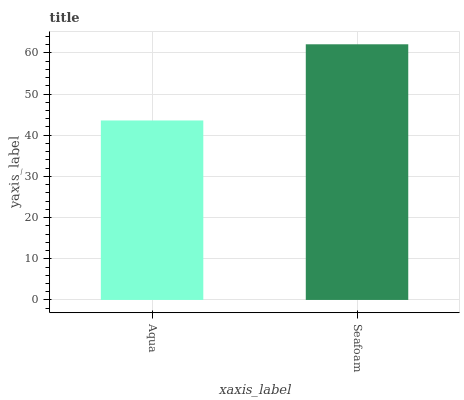Is Aqua the minimum?
Answer yes or no. Yes. Is Seafoam the maximum?
Answer yes or no. Yes. Is Seafoam the minimum?
Answer yes or no. No. Is Seafoam greater than Aqua?
Answer yes or no. Yes. Is Aqua less than Seafoam?
Answer yes or no. Yes. Is Aqua greater than Seafoam?
Answer yes or no. No. Is Seafoam less than Aqua?
Answer yes or no. No. Is Seafoam the high median?
Answer yes or no. Yes. Is Aqua the low median?
Answer yes or no. Yes. Is Aqua the high median?
Answer yes or no. No. Is Seafoam the low median?
Answer yes or no. No. 